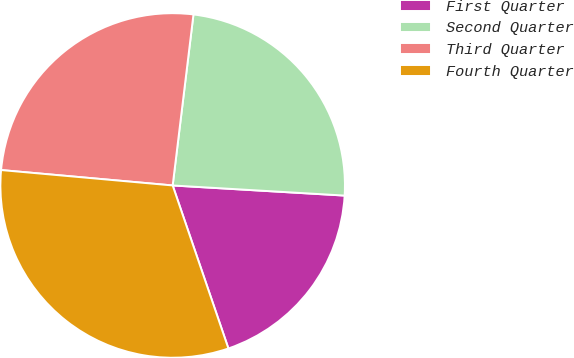Convert chart. <chart><loc_0><loc_0><loc_500><loc_500><pie_chart><fcel>First Quarter<fcel>Second Quarter<fcel>Third Quarter<fcel>Fourth Quarter<nl><fcel>18.82%<fcel>24.01%<fcel>25.5%<fcel>31.67%<nl></chart> 